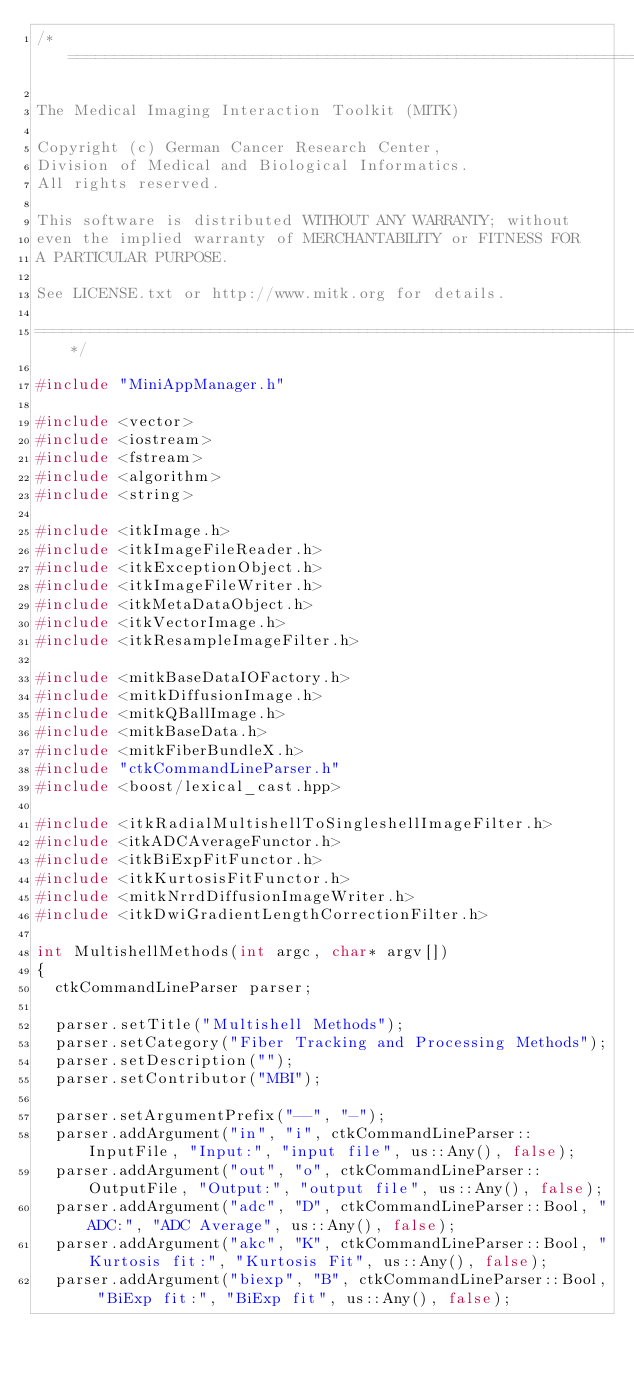Convert code to text. <code><loc_0><loc_0><loc_500><loc_500><_C++_>/*===================================================================

The Medical Imaging Interaction Toolkit (MITK)

Copyright (c) German Cancer Research Center,
Division of Medical and Biological Informatics.
All rights reserved.

This software is distributed WITHOUT ANY WARRANTY; without
even the implied warranty of MERCHANTABILITY or FITNESS FOR
A PARTICULAR PURPOSE.

See LICENSE.txt or http://www.mitk.org for details.

===================================================================*/

#include "MiniAppManager.h"

#include <vector>
#include <iostream>
#include <fstream>
#include <algorithm>
#include <string>

#include <itkImage.h>
#include <itkImageFileReader.h>
#include <itkExceptionObject.h>
#include <itkImageFileWriter.h>
#include <itkMetaDataObject.h>
#include <itkVectorImage.h>
#include <itkResampleImageFilter.h>

#include <mitkBaseDataIOFactory.h>
#include <mitkDiffusionImage.h>
#include <mitkQBallImage.h>
#include <mitkBaseData.h>
#include <mitkFiberBundleX.h>
#include "ctkCommandLineParser.h"
#include <boost/lexical_cast.hpp>

#include <itkRadialMultishellToSingleshellImageFilter.h>
#include <itkADCAverageFunctor.h>
#include <itkBiExpFitFunctor.h>
#include <itkKurtosisFitFunctor.h>
#include <mitkNrrdDiffusionImageWriter.h>
#include <itkDwiGradientLengthCorrectionFilter.h>

int MultishellMethods(int argc, char* argv[])
{
  ctkCommandLineParser parser;

  parser.setTitle("Multishell Methods");
  parser.setCategory("Fiber Tracking and Processing Methods");
  parser.setDescription("");
  parser.setContributor("MBI");

  parser.setArgumentPrefix("--", "-");
  parser.addArgument("in", "i", ctkCommandLineParser::InputFile, "Input:", "input file", us::Any(), false);
  parser.addArgument("out", "o", ctkCommandLineParser::OutputFile, "Output:", "output file", us::Any(), false);
  parser.addArgument("adc", "D", ctkCommandLineParser::Bool, "ADC:", "ADC Average", us::Any(), false);
  parser.addArgument("akc", "K", ctkCommandLineParser::Bool, "Kurtosis fit:", "Kurtosis Fit", us::Any(), false);
  parser.addArgument("biexp", "B", ctkCommandLineParser::Bool, "BiExp fit:", "BiExp fit", us::Any(), false);</code> 